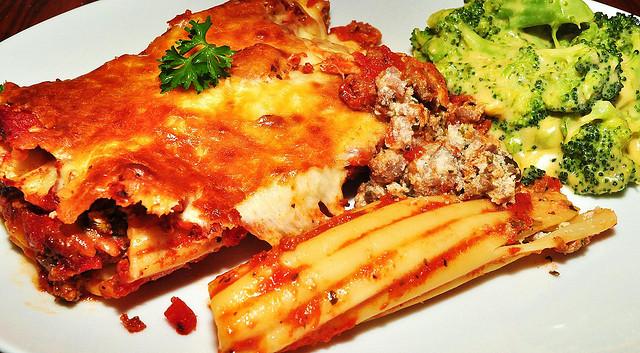What is the red sauce?
Be succinct. Tomato. What are the green things?
Be succinct. Broccoli. Did the person likely make this or buy this?
Short answer required. Make. Has this food been prepared by a chef?
Keep it brief. No. What is the name of this dish?
Be succinct. Lasagna. Is this spaghetti?
Short answer required. No. What is the green garnish on top of the pasta?
Quick response, please. Parsley. 